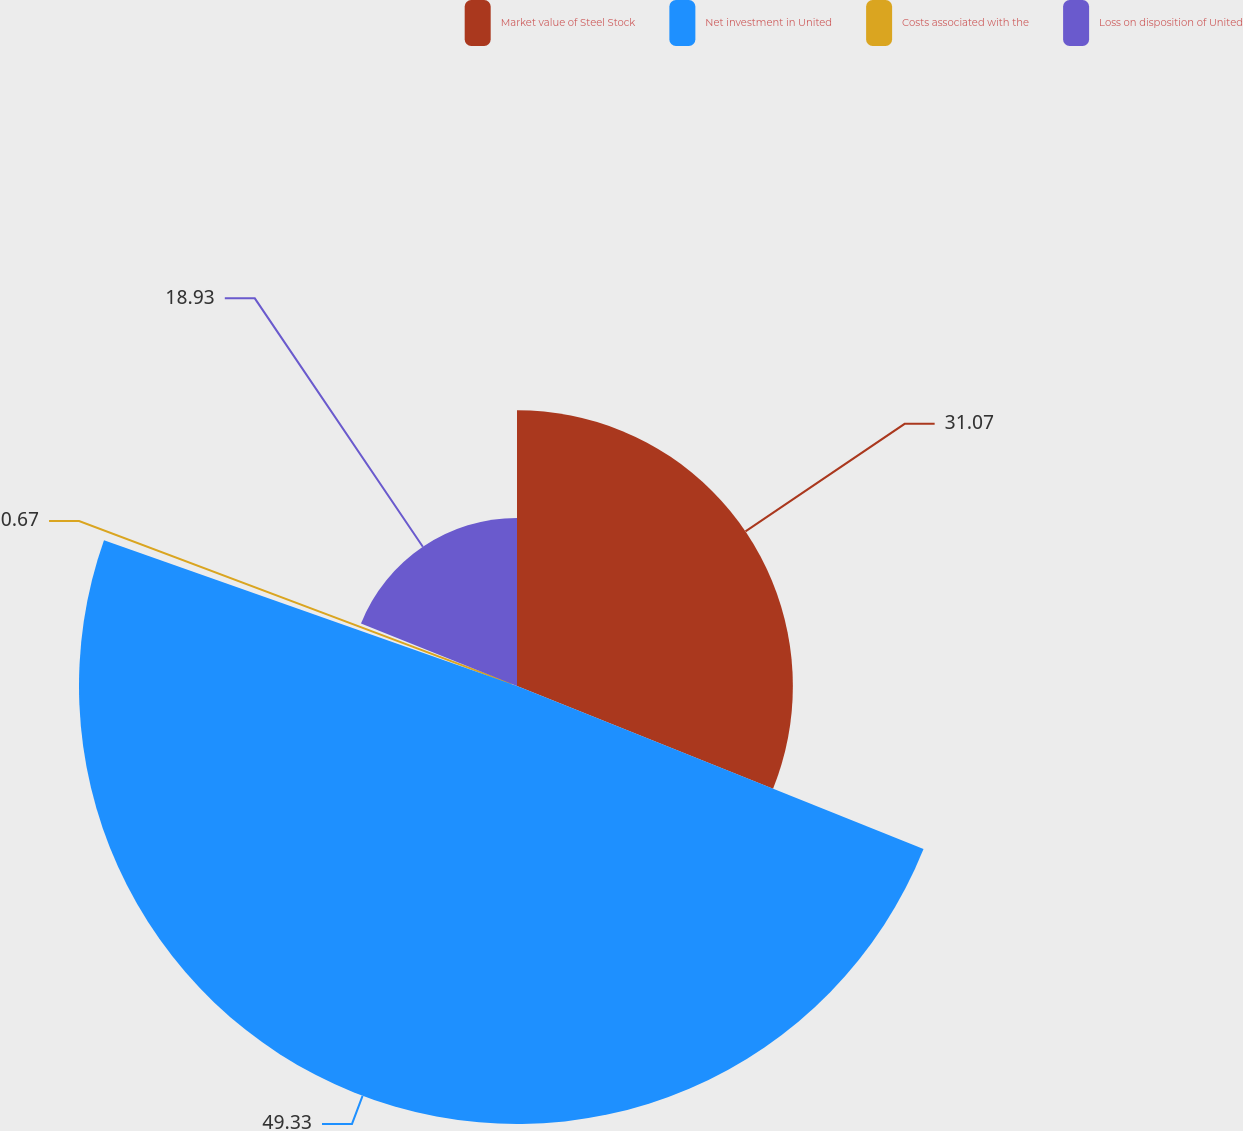Convert chart to OTSL. <chart><loc_0><loc_0><loc_500><loc_500><pie_chart><fcel>Market value of Steel Stock<fcel>Net investment in United<fcel>Costs associated with the<fcel>Loss on disposition of United<nl><fcel>31.07%<fcel>49.33%<fcel>0.67%<fcel>18.93%<nl></chart> 